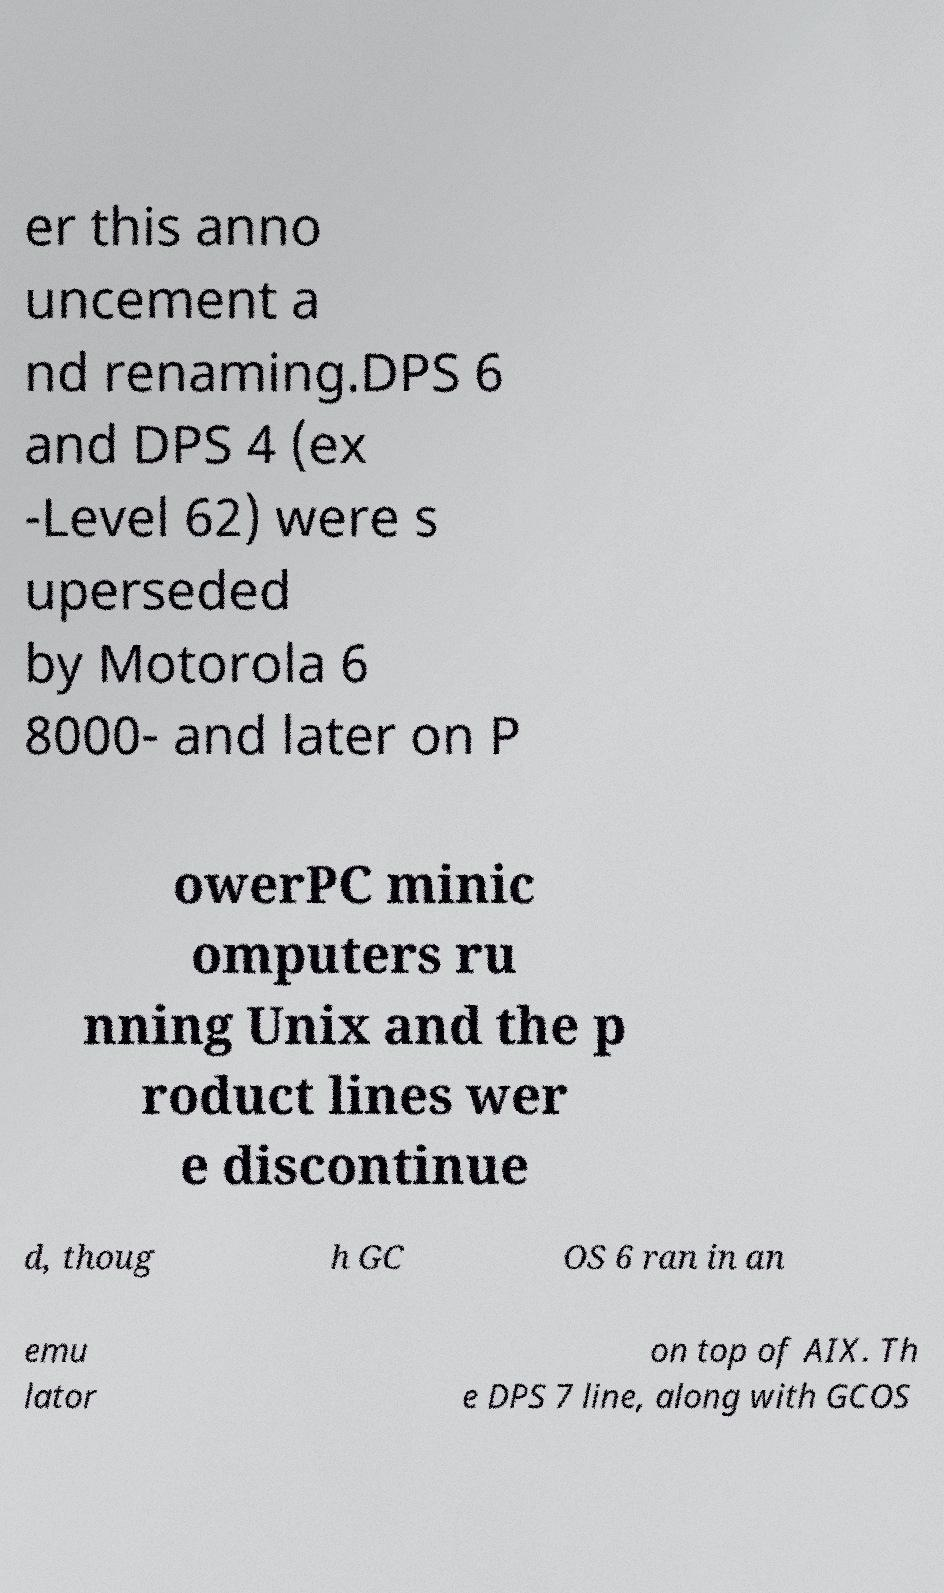Please read and relay the text visible in this image. What does it say? er this anno uncement a nd renaming.DPS 6 and DPS 4 (ex -Level 62) were s uperseded by Motorola 6 8000- and later on P owerPC minic omputers ru nning Unix and the p roduct lines wer e discontinue d, thoug h GC OS 6 ran in an emu lator on top of AIX. Th e DPS 7 line, along with GCOS 